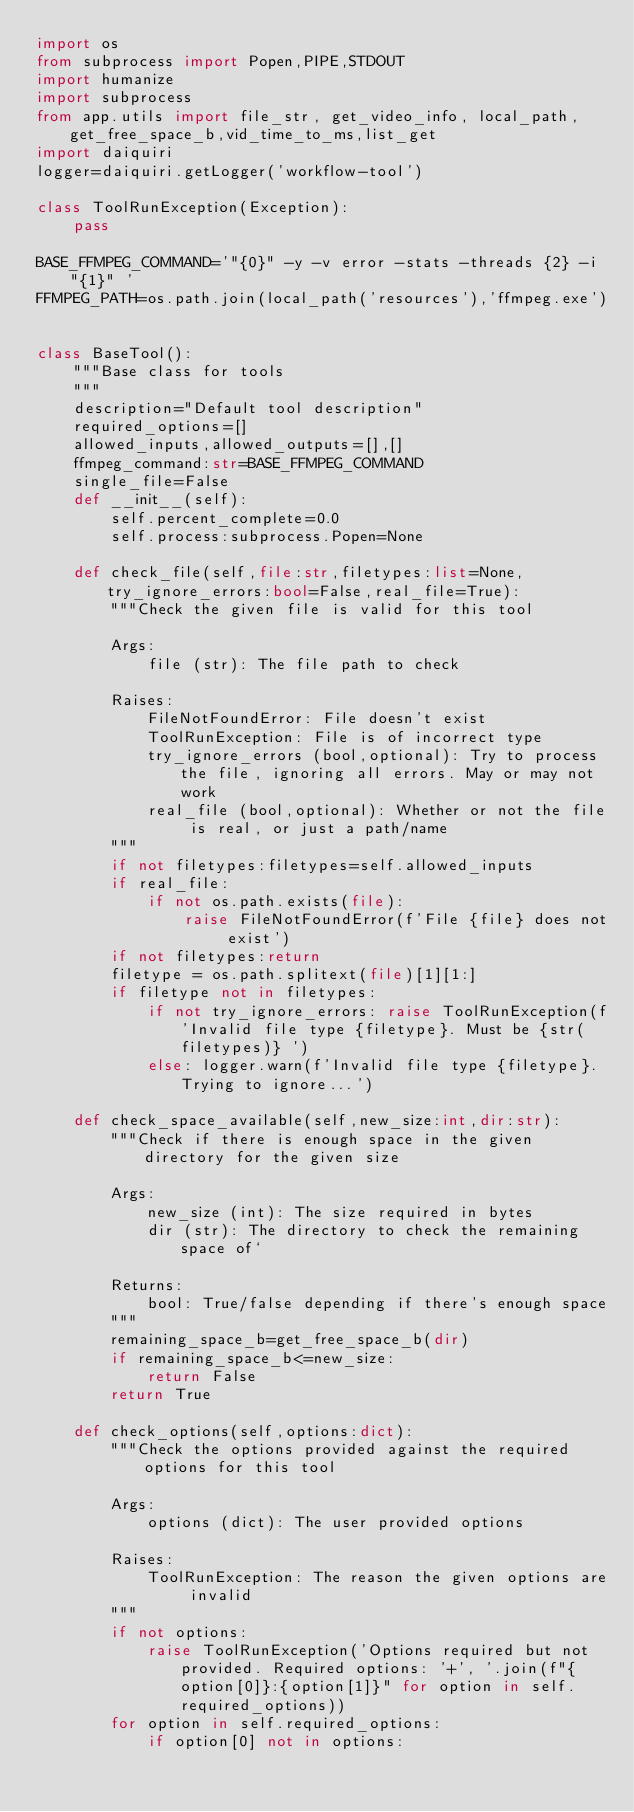<code> <loc_0><loc_0><loc_500><loc_500><_Python_>import os
from subprocess import Popen,PIPE,STDOUT
import humanize
import subprocess
from app.utils import file_str, get_video_info, local_path,get_free_space_b,vid_time_to_ms,list_get
import daiquiri
logger=daiquiri.getLogger('workflow-tool')

class ToolRunException(Exception):
    pass

BASE_FFMPEG_COMMAND='"{0}" -y -v error -stats -threads {2} -i "{1}" '
FFMPEG_PATH=os.path.join(local_path('resources'),'ffmpeg.exe')


class BaseTool():
    """Base class for tools
    """
    description="Default tool description"
    required_options=[]
    allowed_inputs,allowed_outputs=[],[]
    ffmpeg_command:str=BASE_FFMPEG_COMMAND
    single_file=False
    def __init__(self):
        self.percent_complete=0.0
        self.process:subprocess.Popen=None

    def check_file(self,file:str,filetypes:list=None,try_ignore_errors:bool=False,real_file=True):
        """Check the given file is valid for this tool

        Args:
            file (str): The file path to check

        Raises:
            FileNotFoundError: File doesn't exist
            ToolRunException: File is of incorrect type
            try_ignore_errors (bool,optional): Try to process the file, ignoring all errors. May or may not work
            real_file (bool,optional): Whether or not the file is real, or just a path/name
        """
        if not filetypes:filetypes=self.allowed_inputs
        if real_file:
            if not os.path.exists(file):
                raise FileNotFoundError(f'File {file} does not exist')
        if not filetypes:return
        filetype = os.path.splitext(file)[1][1:]
        if filetype not in filetypes:
            if not try_ignore_errors: raise ToolRunException(f'Invalid file type {filetype}. Must be {str(filetypes)} ')
            else: logger.warn(f'Invalid file type {filetype}. Trying to ignore...')

    def check_space_available(self,new_size:int,dir:str):
        """Check if there is enough space in the given directory for the given size

        Args:
            new_size (int): The size required in bytes
            dir (str): The directory to check the remaining space of`

        Returns:
            bool: True/false depending if there's enough space
        """
        remaining_space_b=get_free_space_b(dir)
        if remaining_space_b<=new_size:
            return False
        return True

    def check_options(self,options:dict):
        """Check the options provided against the required options for this tool

        Args:
            options (dict): The user provided options

        Raises:
            ToolRunException: The reason the given options are invalid
        """
        if not options:
            raise ToolRunException('Options required but not provided. Required options: '+', '.join(f"{option[0]}:{option[1]}" for option in self.required_options))
        for option in self.required_options:
            if option[0] not in options:</code> 